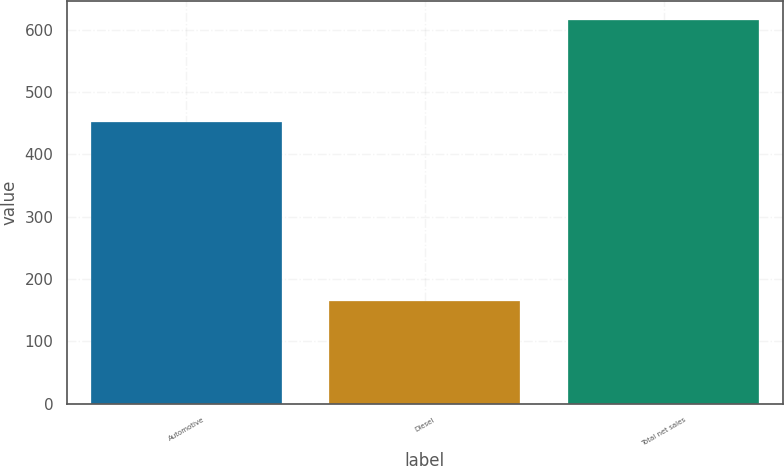Convert chart to OTSL. <chart><loc_0><loc_0><loc_500><loc_500><bar_chart><fcel>Automotive<fcel>Diesel<fcel>Total net sales<nl><fcel>451<fcel>164<fcel>615<nl></chart> 